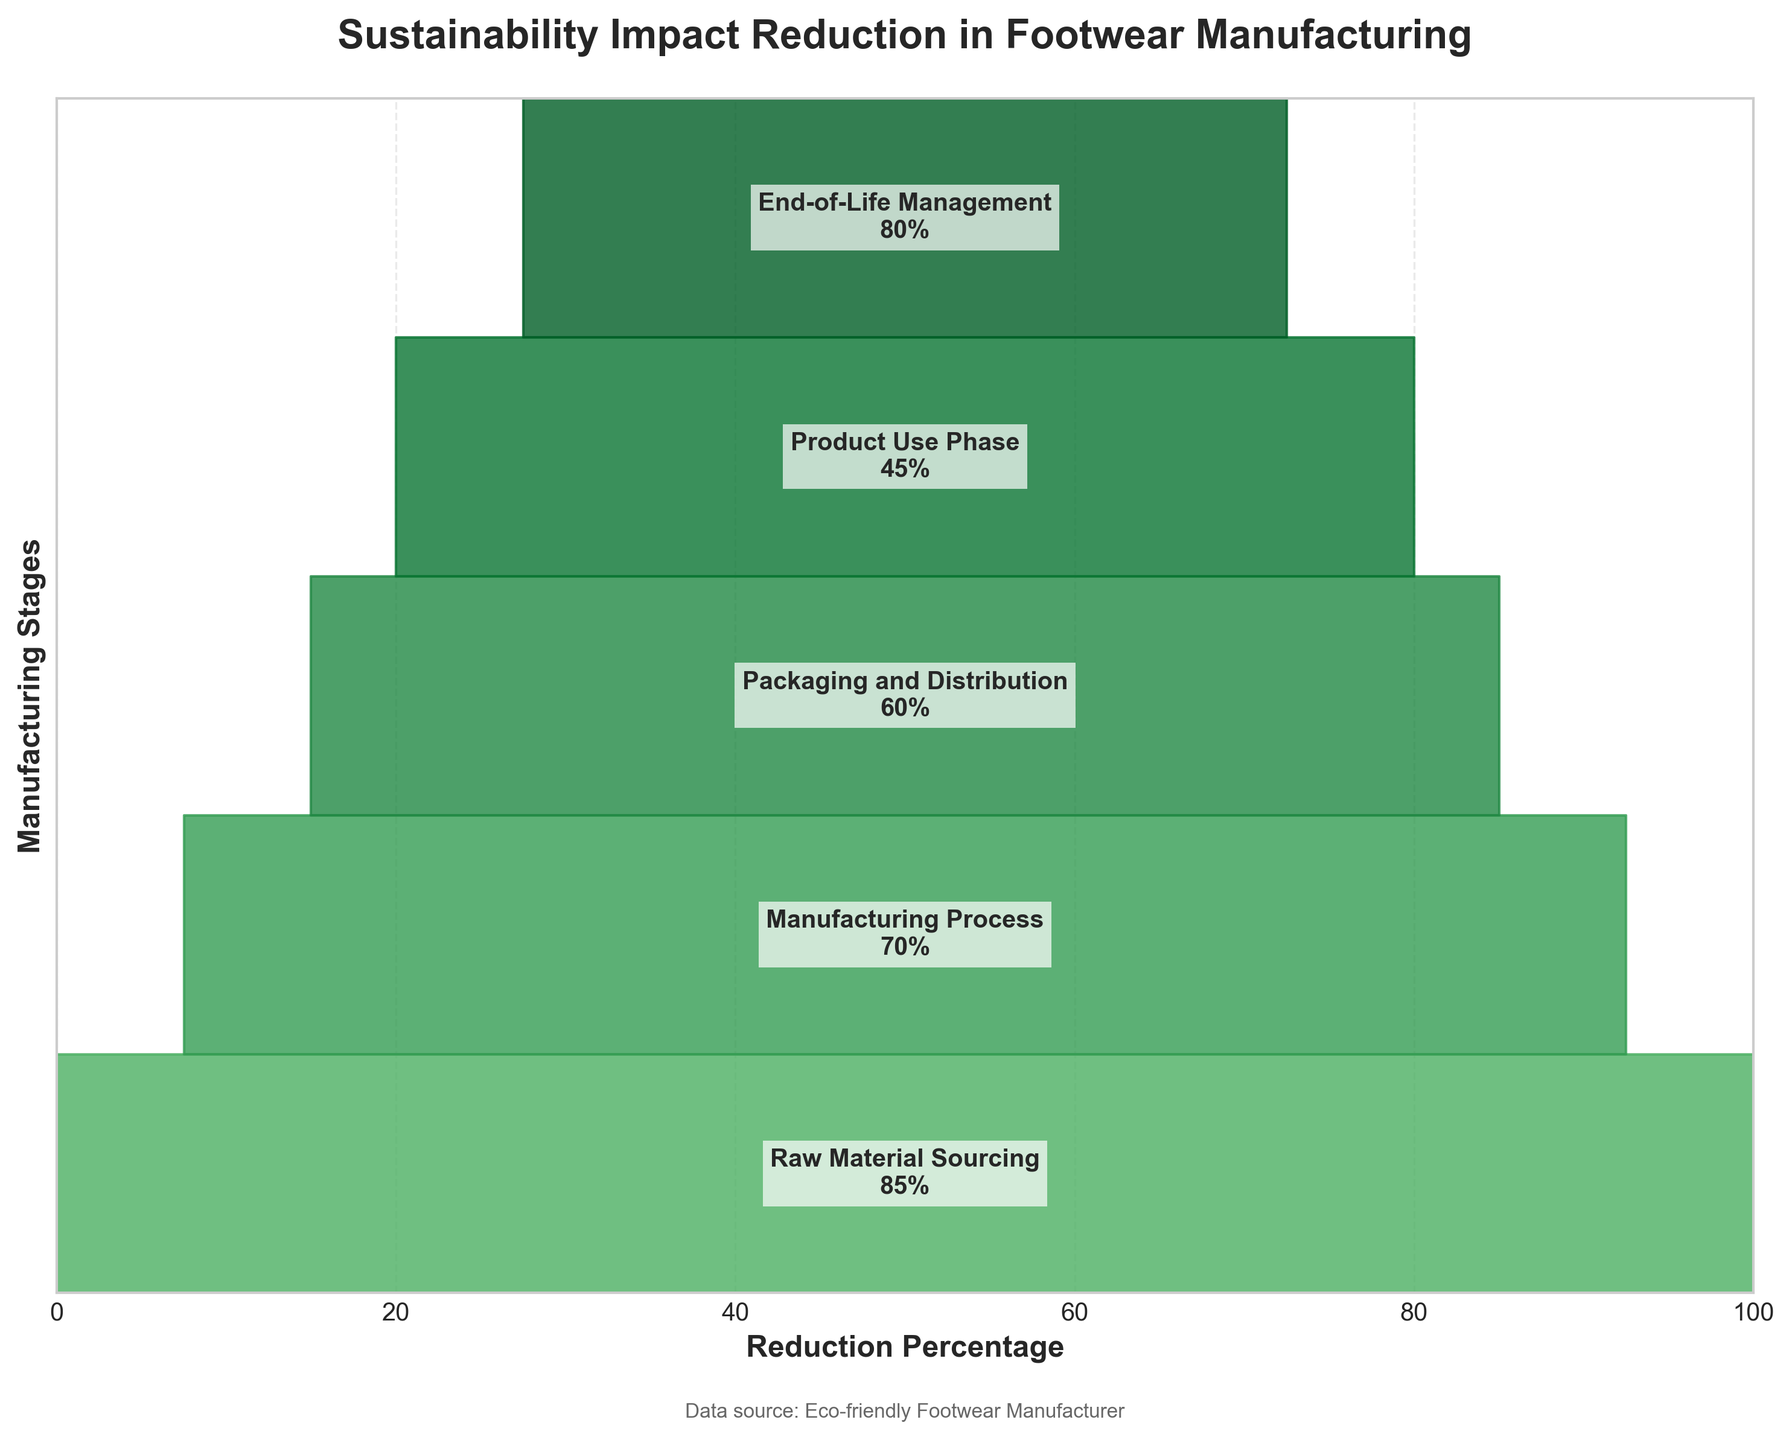What's the title of the figure? The title is usually displayed at the top of the figure. Here, the title is "Sustainability Impact Reduction in Footwear Manufacturing."
Answer: Sustainability Impact Reduction in Footwear Manufacturing How many stages are represented in the funnel chart? The stages can be counted based on the text labels inside the funnel segments. There are 5 stages labeled: Raw Material Sourcing, Manufacturing Process, Packaging and Distribution, Product Use Phase, and End-of-Life Management.
Answer: 5 Which stage has the highest reduction percentage? The reduction percentages are provided within the text inside each funnel segment. The highest value is 85%, which corresponds to the "Raw Material Sourcing" stage.
Answer: Raw Material Sourcing What is the reduction percentage for the "End-of-Life Management" stage? The percentage is written inside the funnel segment labeled "End-of-Life Management." It shows 80%.
Answer: 80% What's the average reduction percentage across all stages? To find the average, sum up all the reduction percentages: 85 + 70 + 60 + 45 + 80 = 340. Then divide by the number of stages: 340 / 5 = 68%.
Answer: 68% Which stage has a reduction percentage less than 50%? Check each percentage inside the funnel segments. The "Product Use Phase" stage is the only one with a reduction of 45%, which is less than 50%.
Answer: Product Use Phase Compare the reduction percentage of "Manufacturing Process" and "Product Use Phase." Which one is higher? "Manufacturing Process" has 70% and "Product Use Phase" has 45%. Since 70% > 45%, the Manufacturing Process has a higher reduction percentage.
Answer: Manufacturing Process By how much does the reduction percentage of "Packaging and Distribution" exceed that of "Product Use Phase"? Subtract the reduction percentage of "Product Use Phase" (45%) from "Packaging and Distribution" (60%): 60 - 45 = 15%.
Answer: 15% What is the total reduction percentage if you combine the reduction percentages from "Manufacturing Process" and "End-of-Life Management"? Sum the two percentages: 70% (Manufacturing Process) + 80% (End-of-Life Management) = 150%.
Answer: 150% In the funnel chart, which stage comes immediately after "Raw Material Sourcing"? The order of the stages follows the progression of the funnel from top to bottom. "Manufacturing Process" comes immediately after "Raw Material Sourcing."
Answer: Manufacturing Process 